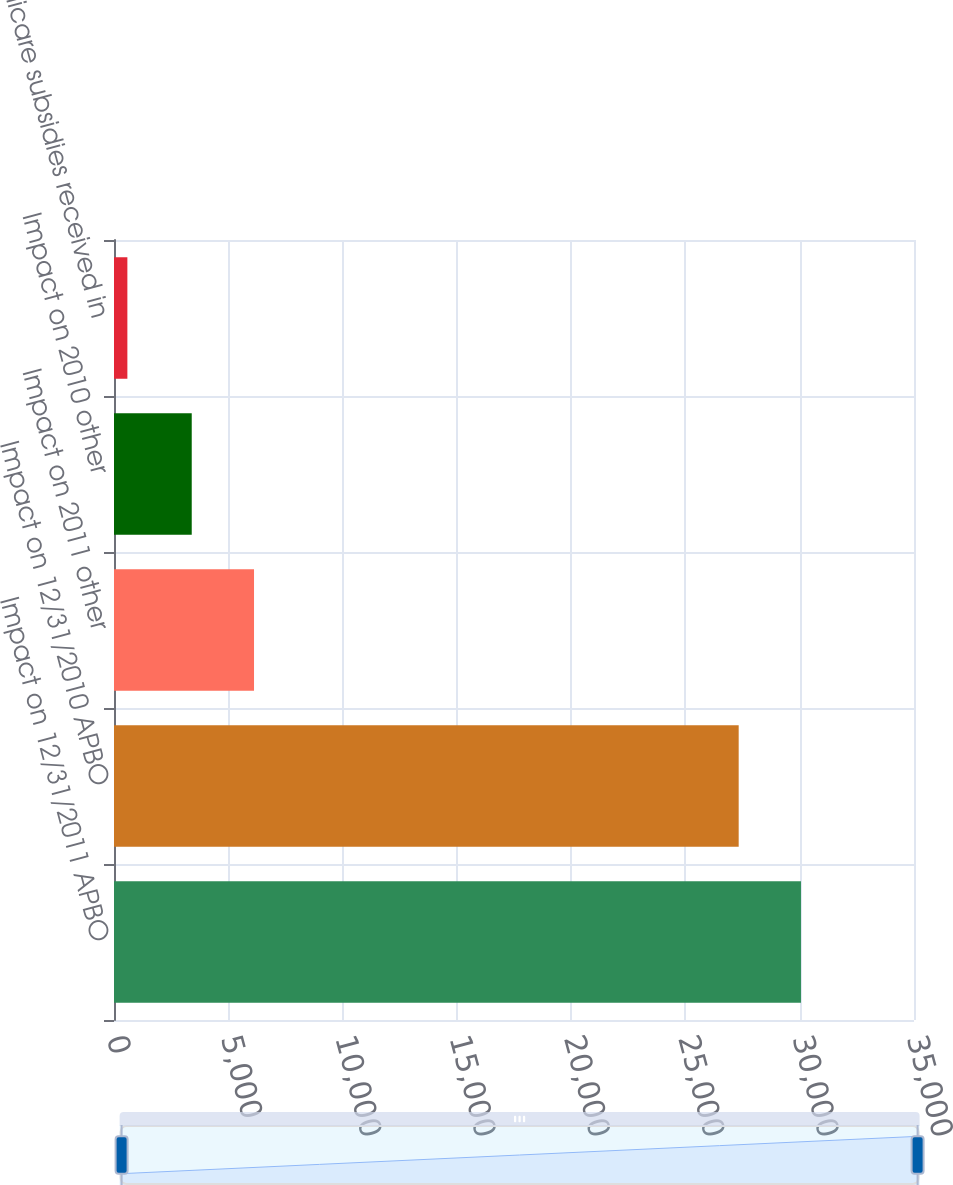Convert chart to OTSL. <chart><loc_0><loc_0><loc_500><loc_500><bar_chart><fcel>Impact on 12/31/2011 APBO<fcel>Impact on 12/31/2010 APBO<fcel>Impact on 2011 other<fcel>Impact on 2010 other<fcel>Medicare subsidies received in<nl><fcel>30054.9<fcel>27330<fcel>6125.9<fcel>3401<fcel>585<nl></chart> 